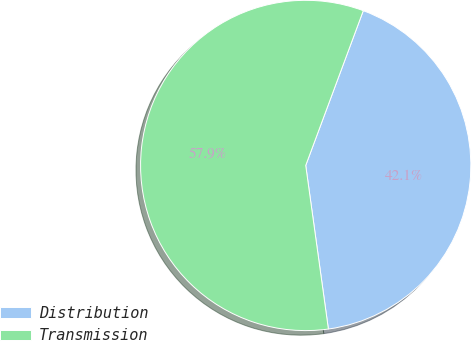Convert chart to OTSL. <chart><loc_0><loc_0><loc_500><loc_500><pie_chart><fcel>Distribution<fcel>Transmission<nl><fcel>42.14%<fcel>57.86%<nl></chart> 